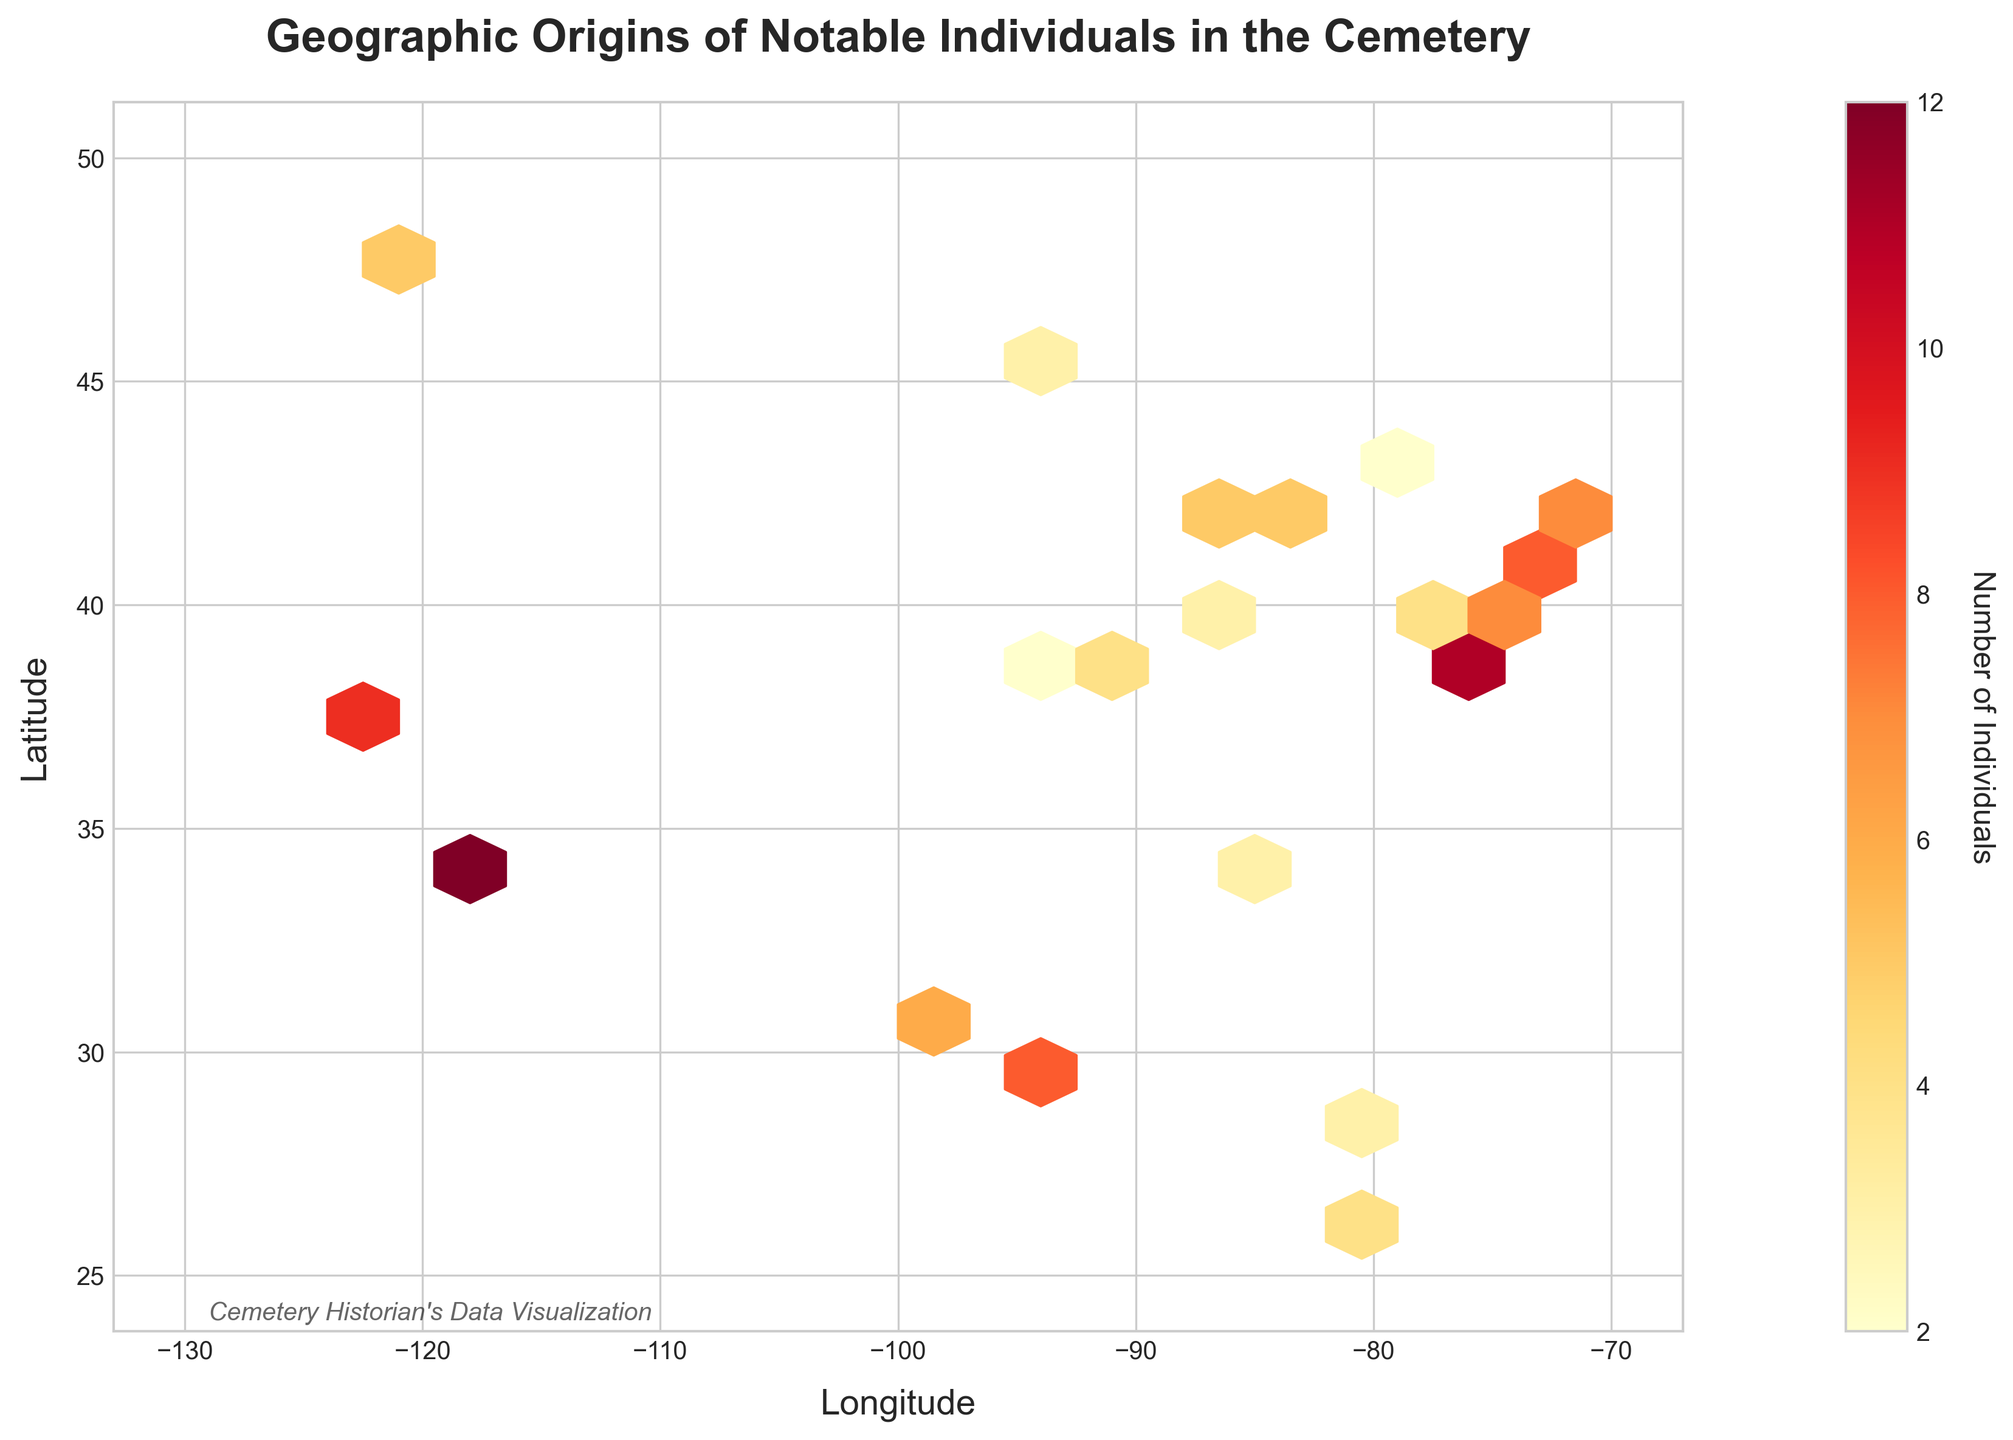What's the title of the plot? The title is typically found at the top of the plot and is meant to describe the content. It's clearly stated at the top.
Answer: Geographic Origins of Notable Individuals in the Cemetery What do the axes represent? Axis labels are found adjacent to the respective axis. The x-axis represents Longitude, and the y-axis represents Latitude.
Answer: Longitude and Latitude What does the color intensity represent in this plot? The color intensity is explained by the color bar on the side of the plot. It indicates the number of individuals from various geographic origins.
Answer: Number of Individuals Where are the highest concentrations of notable individuals from? The hexbin plot shows areas with higher counts in more intense colors. The most intense colors appear around the coordinates (-118.243, 34.052), which is Los Angeles.
Answer: Los Angeles area Which location has the second highest number of individuals buried in the cemetery? By observing the second most intense color on the plot and referring to coordinates, it corresponds to the area around (-122.419, 37.775) which is San Francisco.
Answer: San Francisco area How many individuals are from the New York area? By locating New York on the plot around (-74.006, 40.713) and checking the color intensity matching the number in the color bar, it shows 8 individuals.
Answer: 8 individuals Which city represents the coordinate (-87.629, 41.884) and how many individuals are from there? By identifying coordinates on the map and the corresponding color intensity, (-87.629, 41.884) represents Chicago with a count of 5.
Answer: Chicago, 5 individuals Are there more individuals from Washington D.C. or Boston? Washington D.C. is around (-77.036, 38.895) with a color showing 11 individuals and Boston is around (-71.058, 42.360) with a color showing 7 individuals. By comparing these numbers, D.C. has more.
Answer: Washington D.C Which city has a higher number of individuals buried in the cemetery: Minneapolis or Seattle? Minneapolis is at (-93.265, 44.977) with 3 individuals, while Seattle is at (-122.332, 47.606) with 5 individuals. Comparing these numbers, Seattle has more.
Answer: Seattle What is the total number of individuals from New York, Los Angeles, and San Francisco combined? Summing up the number of individuals from these cities: New York (8) + Los Angeles (12) + San Francisco (9) = 29.
Answer: 29 individuals 